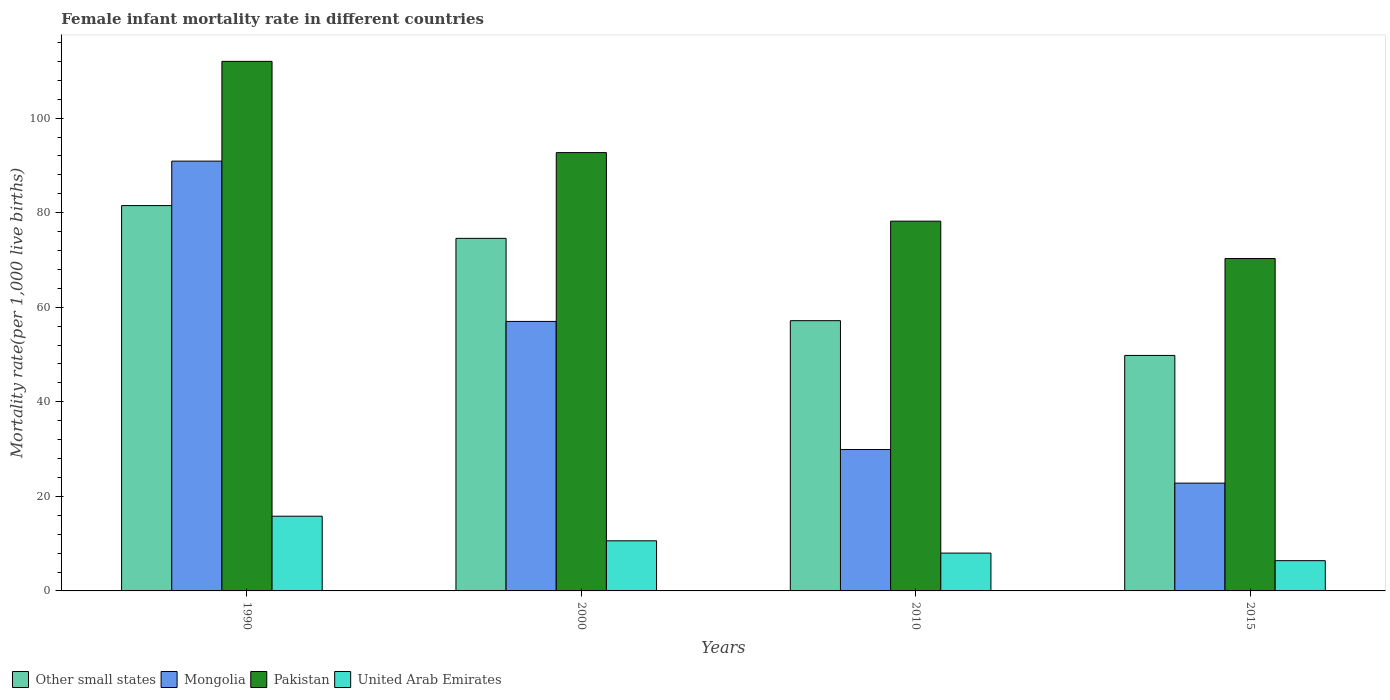How many different coloured bars are there?
Ensure brevity in your answer.  4. How many bars are there on the 2nd tick from the right?
Offer a terse response. 4. In how many cases, is the number of bars for a given year not equal to the number of legend labels?
Your answer should be compact. 0. What is the female infant mortality rate in Other small states in 2010?
Your answer should be very brief. 57.16. Across all years, what is the maximum female infant mortality rate in Pakistan?
Make the answer very short. 112. Across all years, what is the minimum female infant mortality rate in Mongolia?
Your answer should be compact. 22.8. In which year was the female infant mortality rate in Mongolia maximum?
Keep it short and to the point. 1990. In which year was the female infant mortality rate in Mongolia minimum?
Give a very brief answer. 2015. What is the total female infant mortality rate in Other small states in the graph?
Keep it short and to the point. 263.03. What is the difference between the female infant mortality rate in Pakistan in 2000 and that in 2010?
Your answer should be very brief. 14.5. What is the difference between the female infant mortality rate in Other small states in 2000 and the female infant mortality rate in Pakistan in 1990?
Your response must be concise. -37.43. What is the average female infant mortality rate in Pakistan per year?
Keep it short and to the point. 88.3. In the year 2015, what is the difference between the female infant mortality rate in Other small states and female infant mortality rate in United Arab Emirates?
Provide a short and direct response. 43.41. In how many years, is the female infant mortality rate in Pakistan greater than 40?
Keep it short and to the point. 4. What is the ratio of the female infant mortality rate in Mongolia in 2000 to that in 2010?
Make the answer very short. 1.91. Is the difference between the female infant mortality rate in Other small states in 1990 and 2015 greater than the difference between the female infant mortality rate in United Arab Emirates in 1990 and 2015?
Give a very brief answer. Yes. What is the difference between the highest and the second highest female infant mortality rate in Other small states?
Give a very brief answer. 6.93. What is the difference between the highest and the lowest female infant mortality rate in Pakistan?
Ensure brevity in your answer.  41.7. In how many years, is the female infant mortality rate in Pakistan greater than the average female infant mortality rate in Pakistan taken over all years?
Make the answer very short. 2. What does the 3rd bar from the right in 2010 represents?
Offer a very short reply. Mongolia. How many years are there in the graph?
Give a very brief answer. 4. What is the difference between two consecutive major ticks on the Y-axis?
Ensure brevity in your answer.  20. Are the values on the major ticks of Y-axis written in scientific E-notation?
Make the answer very short. No. Does the graph contain grids?
Keep it short and to the point. No. How are the legend labels stacked?
Your response must be concise. Horizontal. What is the title of the graph?
Offer a terse response. Female infant mortality rate in different countries. What is the label or title of the Y-axis?
Offer a very short reply. Mortality rate(per 1,0 live births). What is the Mortality rate(per 1,000 live births) of Other small states in 1990?
Provide a short and direct response. 81.5. What is the Mortality rate(per 1,000 live births) of Mongolia in 1990?
Provide a succinct answer. 90.9. What is the Mortality rate(per 1,000 live births) of Pakistan in 1990?
Your response must be concise. 112. What is the Mortality rate(per 1,000 live births) in Other small states in 2000?
Give a very brief answer. 74.57. What is the Mortality rate(per 1,000 live births) in Mongolia in 2000?
Give a very brief answer. 57. What is the Mortality rate(per 1,000 live births) in Pakistan in 2000?
Provide a short and direct response. 92.7. What is the Mortality rate(per 1,000 live births) in Other small states in 2010?
Offer a very short reply. 57.16. What is the Mortality rate(per 1,000 live births) in Mongolia in 2010?
Offer a terse response. 29.9. What is the Mortality rate(per 1,000 live births) of Pakistan in 2010?
Your answer should be compact. 78.2. What is the Mortality rate(per 1,000 live births) of United Arab Emirates in 2010?
Provide a short and direct response. 8. What is the Mortality rate(per 1,000 live births) in Other small states in 2015?
Give a very brief answer. 49.81. What is the Mortality rate(per 1,000 live births) of Mongolia in 2015?
Keep it short and to the point. 22.8. What is the Mortality rate(per 1,000 live births) of Pakistan in 2015?
Your answer should be very brief. 70.3. What is the Mortality rate(per 1,000 live births) in United Arab Emirates in 2015?
Offer a terse response. 6.4. Across all years, what is the maximum Mortality rate(per 1,000 live births) of Other small states?
Your answer should be very brief. 81.5. Across all years, what is the maximum Mortality rate(per 1,000 live births) of Mongolia?
Offer a very short reply. 90.9. Across all years, what is the maximum Mortality rate(per 1,000 live births) in Pakistan?
Ensure brevity in your answer.  112. Across all years, what is the maximum Mortality rate(per 1,000 live births) of United Arab Emirates?
Keep it short and to the point. 15.8. Across all years, what is the minimum Mortality rate(per 1,000 live births) of Other small states?
Provide a succinct answer. 49.81. Across all years, what is the minimum Mortality rate(per 1,000 live births) of Mongolia?
Offer a very short reply. 22.8. Across all years, what is the minimum Mortality rate(per 1,000 live births) in Pakistan?
Offer a very short reply. 70.3. Across all years, what is the minimum Mortality rate(per 1,000 live births) of United Arab Emirates?
Make the answer very short. 6.4. What is the total Mortality rate(per 1,000 live births) in Other small states in the graph?
Provide a short and direct response. 263.03. What is the total Mortality rate(per 1,000 live births) in Mongolia in the graph?
Offer a terse response. 200.6. What is the total Mortality rate(per 1,000 live births) of Pakistan in the graph?
Offer a terse response. 353.2. What is the total Mortality rate(per 1,000 live births) of United Arab Emirates in the graph?
Offer a very short reply. 40.8. What is the difference between the Mortality rate(per 1,000 live births) of Other small states in 1990 and that in 2000?
Offer a very short reply. 6.93. What is the difference between the Mortality rate(per 1,000 live births) in Mongolia in 1990 and that in 2000?
Provide a succinct answer. 33.9. What is the difference between the Mortality rate(per 1,000 live births) of Pakistan in 1990 and that in 2000?
Provide a succinct answer. 19.3. What is the difference between the Mortality rate(per 1,000 live births) in United Arab Emirates in 1990 and that in 2000?
Your answer should be very brief. 5.2. What is the difference between the Mortality rate(per 1,000 live births) in Other small states in 1990 and that in 2010?
Provide a short and direct response. 24.34. What is the difference between the Mortality rate(per 1,000 live births) in Pakistan in 1990 and that in 2010?
Provide a succinct answer. 33.8. What is the difference between the Mortality rate(per 1,000 live births) of Other small states in 1990 and that in 2015?
Ensure brevity in your answer.  31.69. What is the difference between the Mortality rate(per 1,000 live births) of Mongolia in 1990 and that in 2015?
Provide a short and direct response. 68.1. What is the difference between the Mortality rate(per 1,000 live births) in Pakistan in 1990 and that in 2015?
Provide a short and direct response. 41.7. What is the difference between the Mortality rate(per 1,000 live births) in Other small states in 2000 and that in 2010?
Your answer should be very brief. 17.41. What is the difference between the Mortality rate(per 1,000 live births) of Mongolia in 2000 and that in 2010?
Your answer should be very brief. 27.1. What is the difference between the Mortality rate(per 1,000 live births) of Pakistan in 2000 and that in 2010?
Offer a very short reply. 14.5. What is the difference between the Mortality rate(per 1,000 live births) in United Arab Emirates in 2000 and that in 2010?
Provide a succinct answer. 2.6. What is the difference between the Mortality rate(per 1,000 live births) of Other small states in 2000 and that in 2015?
Ensure brevity in your answer.  24.76. What is the difference between the Mortality rate(per 1,000 live births) in Mongolia in 2000 and that in 2015?
Offer a very short reply. 34.2. What is the difference between the Mortality rate(per 1,000 live births) of Pakistan in 2000 and that in 2015?
Make the answer very short. 22.4. What is the difference between the Mortality rate(per 1,000 live births) in Other small states in 2010 and that in 2015?
Give a very brief answer. 7.35. What is the difference between the Mortality rate(per 1,000 live births) of Mongolia in 2010 and that in 2015?
Give a very brief answer. 7.1. What is the difference between the Mortality rate(per 1,000 live births) in Other small states in 1990 and the Mortality rate(per 1,000 live births) in Mongolia in 2000?
Your response must be concise. 24.5. What is the difference between the Mortality rate(per 1,000 live births) of Other small states in 1990 and the Mortality rate(per 1,000 live births) of Pakistan in 2000?
Keep it short and to the point. -11.2. What is the difference between the Mortality rate(per 1,000 live births) in Other small states in 1990 and the Mortality rate(per 1,000 live births) in United Arab Emirates in 2000?
Your answer should be very brief. 70.9. What is the difference between the Mortality rate(per 1,000 live births) in Mongolia in 1990 and the Mortality rate(per 1,000 live births) in United Arab Emirates in 2000?
Give a very brief answer. 80.3. What is the difference between the Mortality rate(per 1,000 live births) of Pakistan in 1990 and the Mortality rate(per 1,000 live births) of United Arab Emirates in 2000?
Offer a terse response. 101.4. What is the difference between the Mortality rate(per 1,000 live births) in Other small states in 1990 and the Mortality rate(per 1,000 live births) in Mongolia in 2010?
Your answer should be compact. 51.6. What is the difference between the Mortality rate(per 1,000 live births) of Other small states in 1990 and the Mortality rate(per 1,000 live births) of Pakistan in 2010?
Provide a short and direct response. 3.3. What is the difference between the Mortality rate(per 1,000 live births) in Other small states in 1990 and the Mortality rate(per 1,000 live births) in United Arab Emirates in 2010?
Offer a very short reply. 73.5. What is the difference between the Mortality rate(per 1,000 live births) in Mongolia in 1990 and the Mortality rate(per 1,000 live births) in Pakistan in 2010?
Ensure brevity in your answer.  12.7. What is the difference between the Mortality rate(per 1,000 live births) of Mongolia in 1990 and the Mortality rate(per 1,000 live births) of United Arab Emirates in 2010?
Provide a short and direct response. 82.9. What is the difference between the Mortality rate(per 1,000 live births) in Pakistan in 1990 and the Mortality rate(per 1,000 live births) in United Arab Emirates in 2010?
Make the answer very short. 104. What is the difference between the Mortality rate(per 1,000 live births) of Other small states in 1990 and the Mortality rate(per 1,000 live births) of Mongolia in 2015?
Keep it short and to the point. 58.7. What is the difference between the Mortality rate(per 1,000 live births) of Other small states in 1990 and the Mortality rate(per 1,000 live births) of Pakistan in 2015?
Provide a succinct answer. 11.2. What is the difference between the Mortality rate(per 1,000 live births) of Other small states in 1990 and the Mortality rate(per 1,000 live births) of United Arab Emirates in 2015?
Offer a very short reply. 75.1. What is the difference between the Mortality rate(per 1,000 live births) in Mongolia in 1990 and the Mortality rate(per 1,000 live births) in Pakistan in 2015?
Your answer should be very brief. 20.6. What is the difference between the Mortality rate(per 1,000 live births) of Mongolia in 1990 and the Mortality rate(per 1,000 live births) of United Arab Emirates in 2015?
Offer a very short reply. 84.5. What is the difference between the Mortality rate(per 1,000 live births) of Pakistan in 1990 and the Mortality rate(per 1,000 live births) of United Arab Emirates in 2015?
Offer a terse response. 105.6. What is the difference between the Mortality rate(per 1,000 live births) of Other small states in 2000 and the Mortality rate(per 1,000 live births) of Mongolia in 2010?
Your answer should be compact. 44.67. What is the difference between the Mortality rate(per 1,000 live births) in Other small states in 2000 and the Mortality rate(per 1,000 live births) in Pakistan in 2010?
Keep it short and to the point. -3.63. What is the difference between the Mortality rate(per 1,000 live births) of Other small states in 2000 and the Mortality rate(per 1,000 live births) of United Arab Emirates in 2010?
Give a very brief answer. 66.57. What is the difference between the Mortality rate(per 1,000 live births) in Mongolia in 2000 and the Mortality rate(per 1,000 live births) in Pakistan in 2010?
Provide a succinct answer. -21.2. What is the difference between the Mortality rate(per 1,000 live births) of Pakistan in 2000 and the Mortality rate(per 1,000 live births) of United Arab Emirates in 2010?
Your response must be concise. 84.7. What is the difference between the Mortality rate(per 1,000 live births) of Other small states in 2000 and the Mortality rate(per 1,000 live births) of Mongolia in 2015?
Provide a short and direct response. 51.77. What is the difference between the Mortality rate(per 1,000 live births) of Other small states in 2000 and the Mortality rate(per 1,000 live births) of Pakistan in 2015?
Provide a short and direct response. 4.27. What is the difference between the Mortality rate(per 1,000 live births) of Other small states in 2000 and the Mortality rate(per 1,000 live births) of United Arab Emirates in 2015?
Your answer should be very brief. 68.17. What is the difference between the Mortality rate(per 1,000 live births) of Mongolia in 2000 and the Mortality rate(per 1,000 live births) of Pakistan in 2015?
Keep it short and to the point. -13.3. What is the difference between the Mortality rate(per 1,000 live births) of Mongolia in 2000 and the Mortality rate(per 1,000 live births) of United Arab Emirates in 2015?
Ensure brevity in your answer.  50.6. What is the difference between the Mortality rate(per 1,000 live births) of Pakistan in 2000 and the Mortality rate(per 1,000 live births) of United Arab Emirates in 2015?
Keep it short and to the point. 86.3. What is the difference between the Mortality rate(per 1,000 live births) in Other small states in 2010 and the Mortality rate(per 1,000 live births) in Mongolia in 2015?
Offer a very short reply. 34.36. What is the difference between the Mortality rate(per 1,000 live births) of Other small states in 2010 and the Mortality rate(per 1,000 live births) of Pakistan in 2015?
Offer a very short reply. -13.14. What is the difference between the Mortality rate(per 1,000 live births) of Other small states in 2010 and the Mortality rate(per 1,000 live births) of United Arab Emirates in 2015?
Ensure brevity in your answer.  50.76. What is the difference between the Mortality rate(per 1,000 live births) of Mongolia in 2010 and the Mortality rate(per 1,000 live births) of Pakistan in 2015?
Your response must be concise. -40.4. What is the difference between the Mortality rate(per 1,000 live births) of Mongolia in 2010 and the Mortality rate(per 1,000 live births) of United Arab Emirates in 2015?
Your answer should be very brief. 23.5. What is the difference between the Mortality rate(per 1,000 live births) of Pakistan in 2010 and the Mortality rate(per 1,000 live births) of United Arab Emirates in 2015?
Provide a short and direct response. 71.8. What is the average Mortality rate(per 1,000 live births) in Other small states per year?
Give a very brief answer. 65.76. What is the average Mortality rate(per 1,000 live births) of Mongolia per year?
Give a very brief answer. 50.15. What is the average Mortality rate(per 1,000 live births) in Pakistan per year?
Your response must be concise. 88.3. In the year 1990, what is the difference between the Mortality rate(per 1,000 live births) of Other small states and Mortality rate(per 1,000 live births) of Mongolia?
Your response must be concise. -9.4. In the year 1990, what is the difference between the Mortality rate(per 1,000 live births) of Other small states and Mortality rate(per 1,000 live births) of Pakistan?
Make the answer very short. -30.5. In the year 1990, what is the difference between the Mortality rate(per 1,000 live births) in Other small states and Mortality rate(per 1,000 live births) in United Arab Emirates?
Offer a terse response. 65.7. In the year 1990, what is the difference between the Mortality rate(per 1,000 live births) in Mongolia and Mortality rate(per 1,000 live births) in Pakistan?
Offer a terse response. -21.1. In the year 1990, what is the difference between the Mortality rate(per 1,000 live births) of Mongolia and Mortality rate(per 1,000 live births) of United Arab Emirates?
Your answer should be very brief. 75.1. In the year 1990, what is the difference between the Mortality rate(per 1,000 live births) in Pakistan and Mortality rate(per 1,000 live births) in United Arab Emirates?
Ensure brevity in your answer.  96.2. In the year 2000, what is the difference between the Mortality rate(per 1,000 live births) in Other small states and Mortality rate(per 1,000 live births) in Mongolia?
Your answer should be compact. 17.57. In the year 2000, what is the difference between the Mortality rate(per 1,000 live births) in Other small states and Mortality rate(per 1,000 live births) in Pakistan?
Provide a short and direct response. -18.13. In the year 2000, what is the difference between the Mortality rate(per 1,000 live births) in Other small states and Mortality rate(per 1,000 live births) in United Arab Emirates?
Provide a succinct answer. 63.97. In the year 2000, what is the difference between the Mortality rate(per 1,000 live births) in Mongolia and Mortality rate(per 1,000 live births) in Pakistan?
Give a very brief answer. -35.7. In the year 2000, what is the difference between the Mortality rate(per 1,000 live births) in Mongolia and Mortality rate(per 1,000 live births) in United Arab Emirates?
Offer a very short reply. 46.4. In the year 2000, what is the difference between the Mortality rate(per 1,000 live births) of Pakistan and Mortality rate(per 1,000 live births) of United Arab Emirates?
Give a very brief answer. 82.1. In the year 2010, what is the difference between the Mortality rate(per 1,000 live births) of Other small states and Mortality rate(per 1,000 live births) of Mongolia?
Ensure brevity in your answer.  27.26. In the year 2010, what is the difference between the Mortality rate(per 1,000 live births) in Other small states and Mortality rate(per 1,000 live births) in Pakistan?
Your answer should be compact. -21.04. In the year 2010, what is the difference between the Mortality rate(per 1,000 live births) of Other small states and Mortality rate(per 1,000 live births) of United Arab Emirates?
Your answer should be compact. 49.16. In the year 2010, what is the difference between the Mortality rate(per 1,000 live births) of Mongolia and Mortality rate(per 1,000 live births) of Pakistan?
Your response must be concise. -48.3. In the year 2010, what is the difference between the Mortality rate(per 1,000 live births) of Mongolia and Mortality rate(per 1,000 live births) of United Arab Emirates?
Provide a short and direct response. 21.9. In the year 2010, what is the difference between the Mortality rate(per 1,000 live births) in Pakistan and Mortality rate(per 1,000 live births) in United Arab Emirates?
Make the answer very short. 70.2. In the year 2015, what is the difference between the Mortality rate(per 1,000 live births) of Other small states and Mortality rate(per 1,000 live births) of Mongolia?
Your response must be concise. 27.01. In the year 2015, what is the difference between the Mortality rate(per 1,000 live births) in Other small states and Mortality rate(per 1,000 live births) in Pakistan?
Offer a very short reply. -20.49. In the year 2015, what is the difference between the Mortality rate(per 1,000 live births) of Other small states and Mortality rate(per 1,000 live births) of United Arab Emirates?
Keep it short and to the point. 43.41. In the year 2015, what is the difference between the Mortality rate(per 1,000 live births) in Mongolia and Mortality rate(per 1,000 live births) in Pakistan?
Offer a very short reply. -47.5. In the year 2015, what is the difference between the Mortality rate(per 1,000 live births) in Pakistan and Mortality rate(per 1,000 live births) in United Arab Emirates?
Your answer should be very brief. 63.9. What is the ratio of the Mortality rate(per 1,000 live births) of Other small states in 1990 to that in 2000?
Your answer should be very brief. 1.09. What is the ratio of the Mortality rate(per 1,000 live births) of Mongolia in 1990 to that in 2000?
Provide a succinct answer. 1.59. What is the ratio of the Mortality rate(per 1,000 live births) of Pakistan in 1990 to that in 2000?
Give a very brief answer. 1.21. What is the ratio of the Mortality rate(per 1,000 live births) in United Arab Emirates in 1990 to that in 2000?
Provide a succinct answer. 1.49. What is the ratio of the Mortality rate(per 1,000 live births) in Other small states in 1990 to that in 2010?
Provide a succinct answer. 1.43. What is the ratio of the Mortality rate(per 1,000 live births) of Mongolia in 1990 to that in 2010?
Provide a short and direct response. 3.04. What is the ratio of the Mortality rate(per 1,000 live births) in Pakistan in 1990 to that in 2010?
Provide a short and direct response. 1.43. What is the ratio of the Mortality rate(per 1,000 live births) of United Arab Emirates in 1990 to that in 2010?
Offer a very short reply. 1.98. What is the ratio of the Mortality rate(per 1,000 live births) of Other small states in 1990 to that in 2015?
Your response must be concise. 1.64. What is the ratio of the Mortality rate(per 1,000 live births) of Mongolia in 1990 to that in 2015?
Your answer should be compact. 3.99. What is the ratio of the Mortality rate(per 1,000 live births) in Pakistan in 1990 to that in 2015?
Provide a succinct answer. 1.59. What is the ratio of the Mortality rate(per 1,000 live births) in United Arab Emirates in 1990 to that in 2015?
Offer a very short reply. 2.47. What is the ratio of the Mortality rate(per 1,000 live births) of Other small states in 2000 to that in 2010?
Your response must be concise. 1.3. What is the ratio of the Mortality rate(per 1,000 live births) of Mongolia in 2000 to that in 2010?
Make the answer very short. 1.91. What is the ratio of the Mortality rate(per 1,000 live births) of Pakistan in 2000 to that in 2010?
Your answer should be very brief. 1.19. What is the ratio of the Mortality rate(per 1,000 live births) in United Arab Emirates in 2000 to that in 2010?
Provide a succinct answer. 1.32. What is the ratio of the Mortality rate(per 1,000 live births) of Other small states in 2000 to that in 2015?
Ensure brevity in your answer.  1.5. What is the ratio of the Mortality rate(per 1,000 live births) of Pakistan in 2000 to that in 2015?
Provide a succinct answer. 1.32. What is the ratio of the Mortality rate(per 1,000 live births) of United Arab Emirates in 2000 to that in 2015?
Offer a terse response. 1.66. What is the ratio of the Mortality rate(per 1,000 live births) of Other small states in 2010 to that in 2015?
Ensure brevity in your answer.  1.15. What is the ratio of the Mortality rate(per 1,000 live births) in Mongolia in 2010 to that in 2015?
Provide a short and direct response. 1.31. What is the ratio of the Mortality rate(per 1,000 live births) of Pakistan in 2010 to that in 2015?
Your response must be concise. 1.11. What is the ratio of the Mortality rate(per 1,000 live births) in United Arab Emirates in 2010 to that in 2015?
Offer a very short reply. 1.25. What is the difference between the highest and the second highest Mortality rate(per 1,000 live births) in Other small states?
Keep it short and to the point. 6.93. What is the difference between the highest and the second highest Mortality rate(per 1,000 live births) in Mongolia?
Provide a succinct answer. 33.9. What is the difference between the highest and the second highest Mortality rate(per 1,000 live births) of Pakistan?
Your answer should be very brief. 19.3. What is the difference between the highest and the second highest Mortality rate(per 1,000 live births) of United Arab Emirates?
Offer a very short reply. 5.2. What is the difference between the highest and the lowest Mortality rate(per 1,000 live births) in Other small states?
Offer a very short reply. 31.69. What is the difference between the highest and the lowest Mortality rate(per 1,000 live births) in Mongolia?
Provide a short and direct response. 68.1. What is the difference between the highest and the lowest Mortality rate(per 1,000 live births) of Pakistan?
Ensure brevity in your answer.  41.7. What is the difference between the highest and the lowest Mortality rate(per 1,000 live births) in United Arab Emirates?
Give a very brief answer. 9.4. 